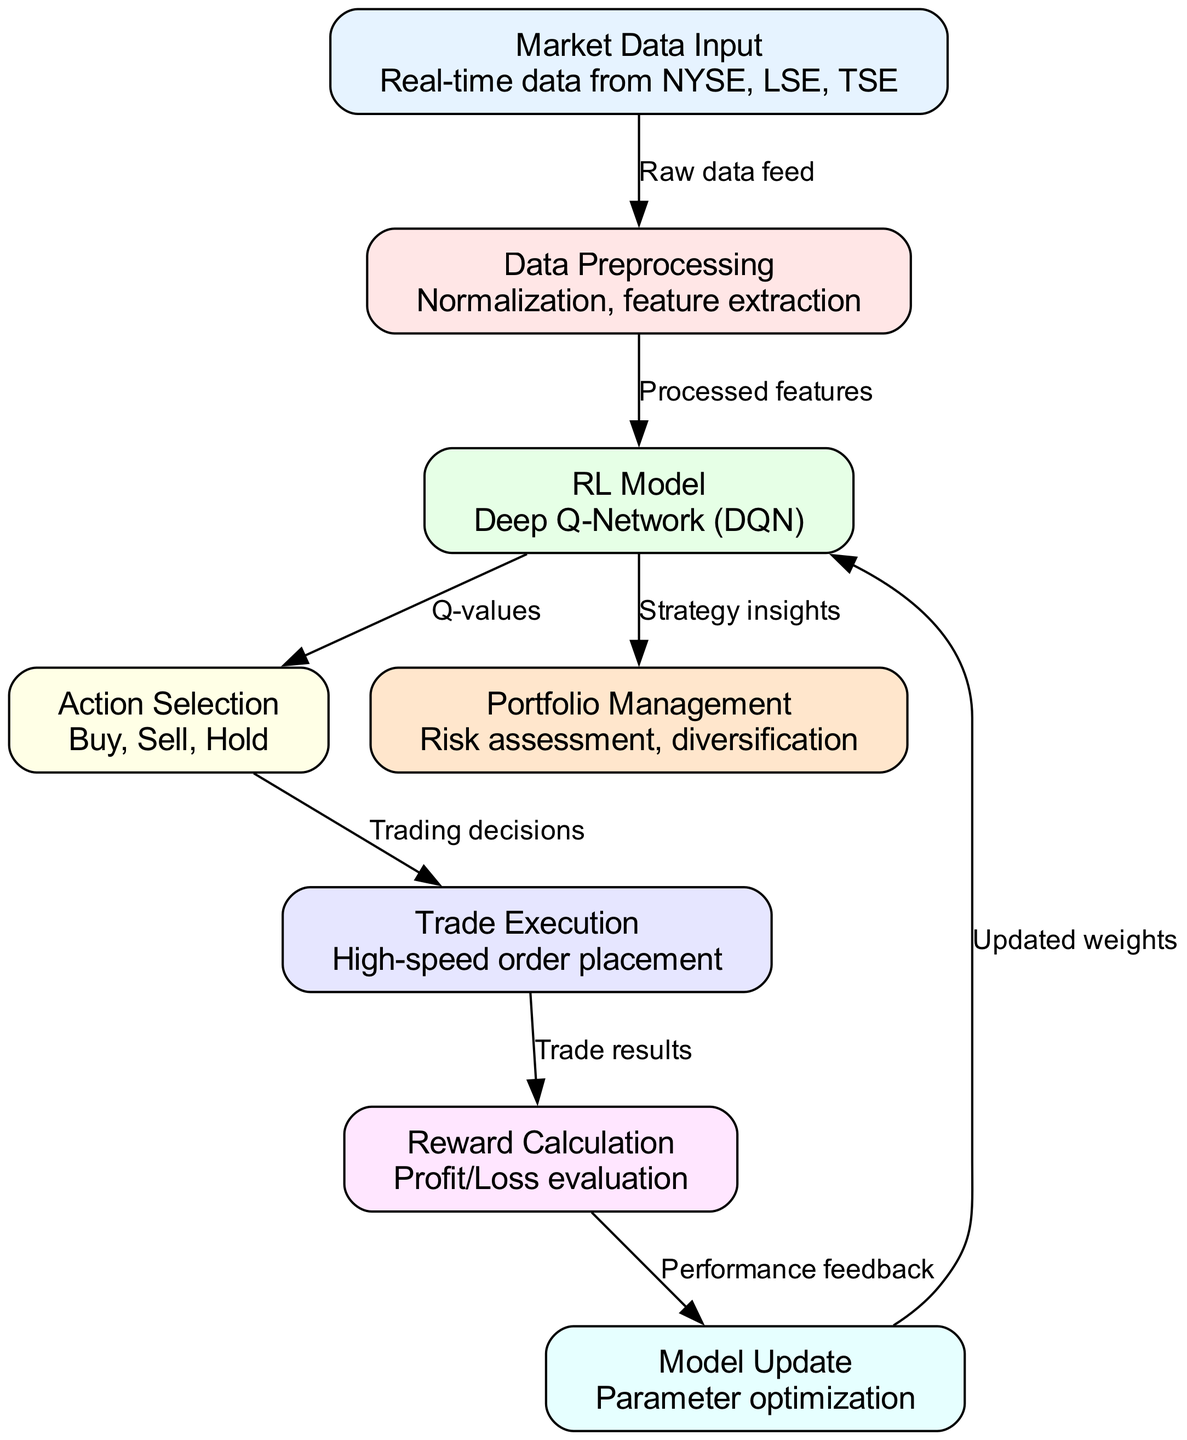What is the first node in the diagram? The first node in the diagram is labeled "Market Data Input". It serves as the initial stage where raw data enters the system for processing.
Answer: Market Data Input How many nodes are present in the diagram? By counting the listed nodes, we find there are eight nodes: Market Data Input, Data Preprocessing, RL Model, Action Selection, Trade Execution, Reward Calculation, Model Update, and Portfolio Management.
Answer: Eight What is the label of the node that follows Data Preprocessing? The node that follows Data Preprocessing is labeled "RL Model". It directly receives processed features and is responsible for decision-making in the trading process.
Answer: RL Model Which nodes are connected to the Trade Execution node? The Trade Execution node is connected to the Action Selection node (which sends trading decisions to it) and sends its results to the Reward Calculation node.
Answer: Action Selection, Reward Calculation What type of model is being used in the RL Model node? The model used in the RL Model node is a "Deep Q-Network (DQN)", which is a type of algorithm used in reinforcement learning for decision-making based on Q-learning.
Answer: Deep Q-Network How does the Reward Calculation node influence the RL Model? The Reward Calculation node influences the RL Model by sending performance feedback to it, which allows the model to learn and optimize its parameters based on the profitability of the trades executed.
Answer: Performance feedback What is the final output from the RL Model node? The final output from the RL Model node is "Strategy insights", which are used for informed decision-making in managing the portfolio based on trading performance and market conditions.
Answer: Strategy insights What flows into Data Preprocessing from the Market Data Input? Raw data feed from the Market Data Input flows into Data Preprocessing, where it is transformed into a suitable format for further analysis and model training.
Answer: Raw data feed 